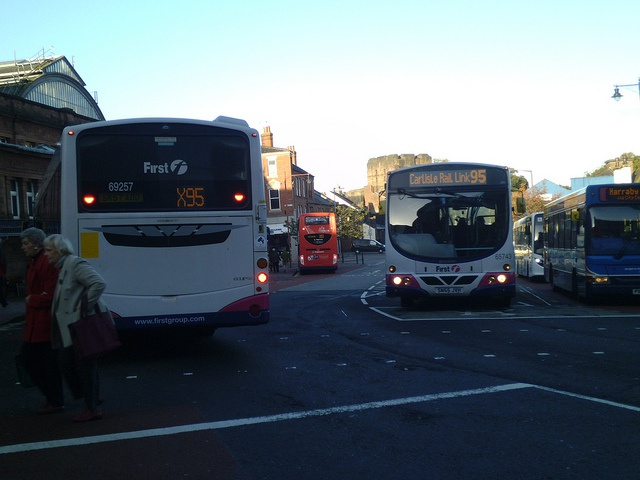Describe the objects in this image and their specific colors. I can see bus in lightblue, black, blue, and navy tones, bus in lightblue, black, gray, navy, and blue tones, bus in lightblue, black, navy, blue, and gray tones, people in lightblue, black, purple, darkblue, and blue tones, and people in lightblue, black, blue, darkblue, and purple tones in this image. 